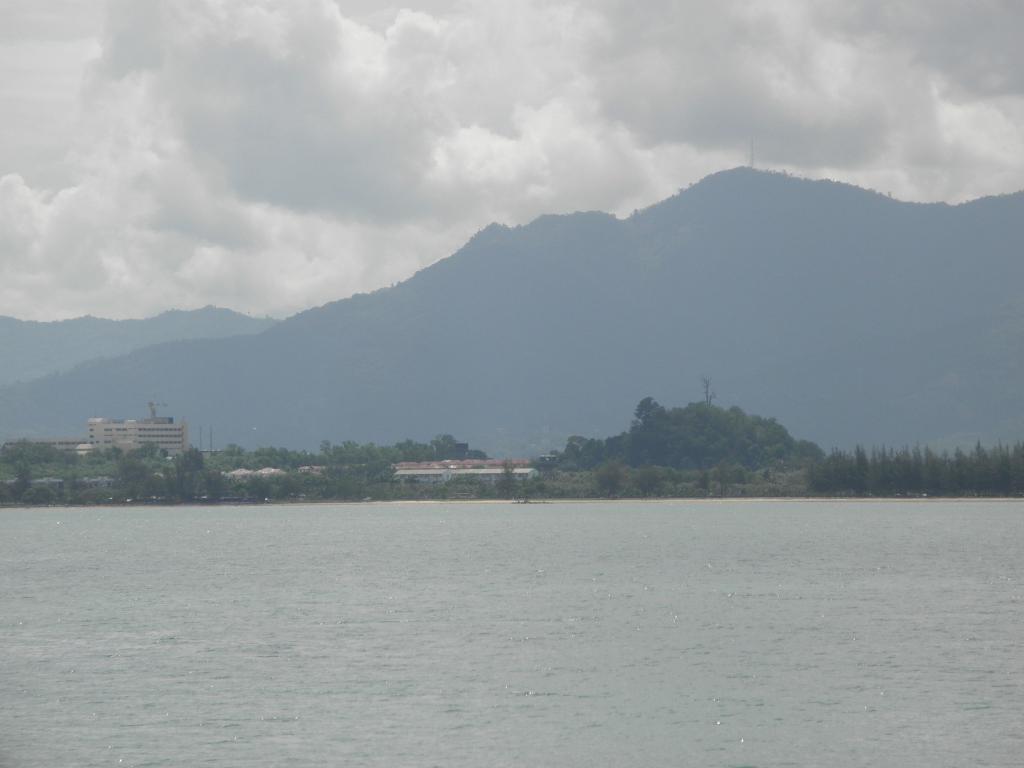In one or two sentences, can you explain what this image depicts? In this image I can see the water surface. I can see few trees. I can see few buildings. In the background I can see mountains. At the top I can see clouds in the sky. 